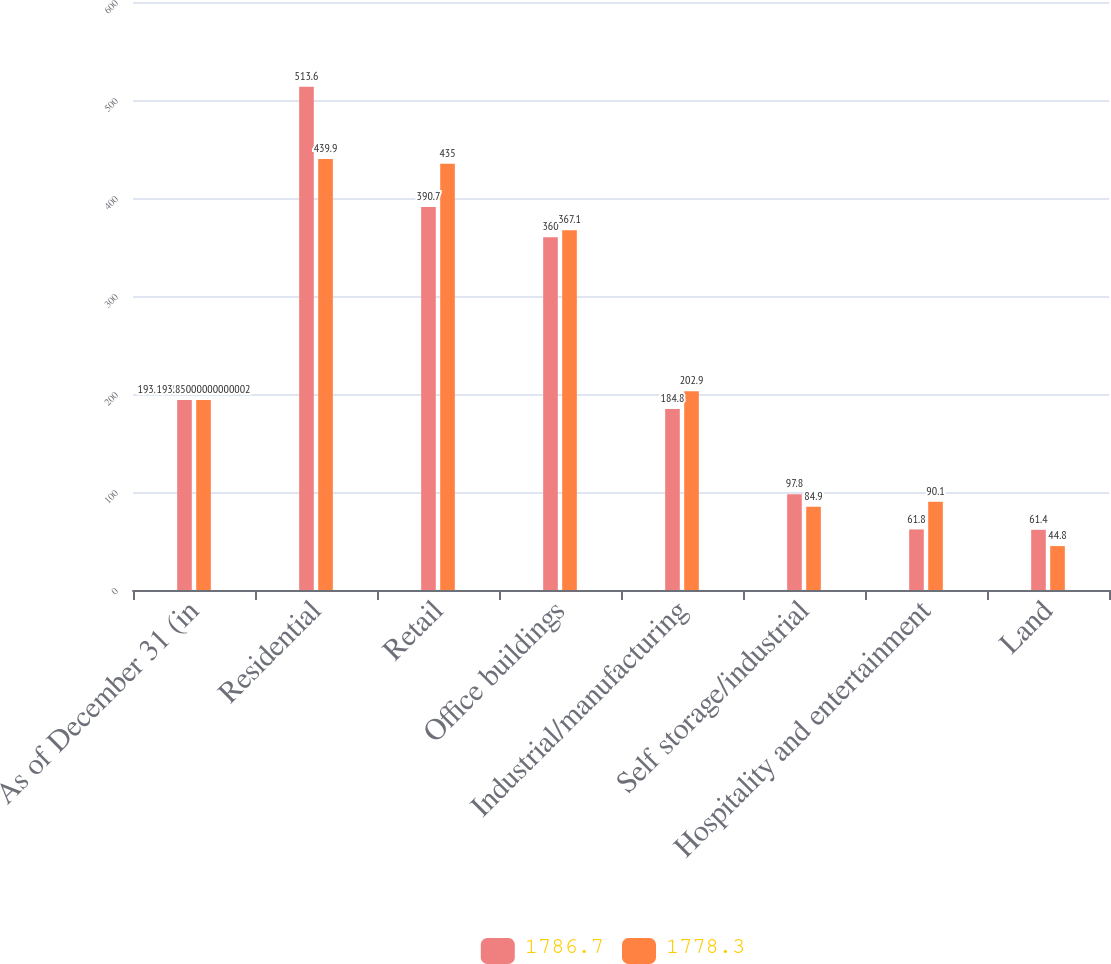<chart> <loc_0><loc_0><loc_500><loc_500><stacked_bar_chart><ecel><fcel>As of December 31 (in<fcel>Residential<fcel>Retail<fcel>Office buildings<fcel>Industrial/manufacturing<fcel>Self storage/industrial<fcel>Hospitality and entertainment<fcel>Land<nl><fcel>1786.7<fcel>193.85<fcel>513.6<fcel>390.7<fcel>360<fcel>184.8<fcel>97.8<fcel>61.8<fcel>61.4<nl><fcel>1778.3<fcel>193.85<fcel>439.9<fcel>435<fcel>367.1<fcel>202.9<fcel>84.9<fcel>90.1<fcel>44.8<nl></chart> 